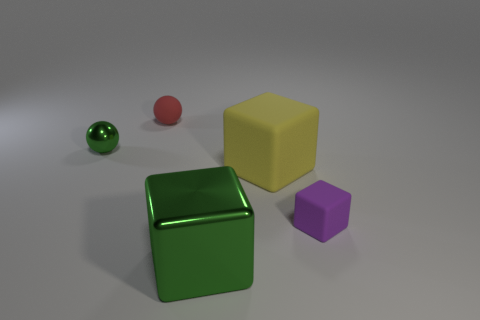What materials do the different objects seem to be made of? The spheres seem to have a smooth, possibly metallic or plastic finish, while the cubes appear matte, suggesting a softer or more porous material, perhaps rubber or another non-reflective substance. 